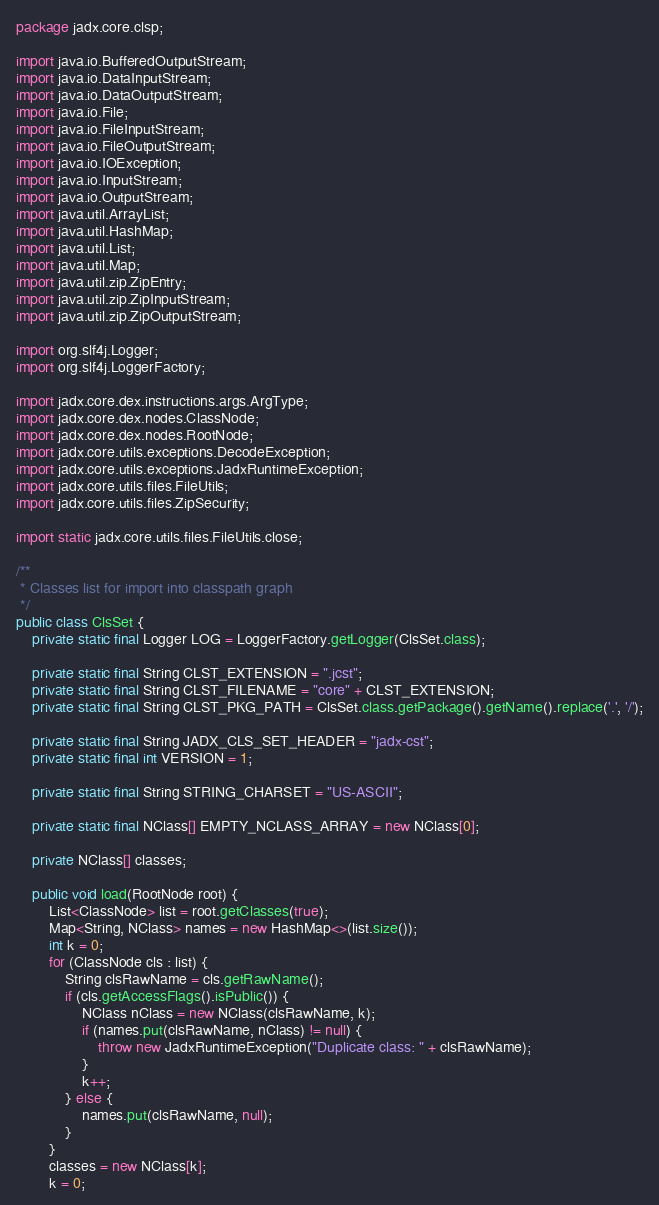<code> <loc_0><loc_0><loc_500><loc_500><_Java_>package jadx.core.clsp;

import java.io.BufferedOutputStream;
import java.io.DataInputStream;
import java.io.DataOutputStream;
import java.io.File;
import java.io.FileInputStream;
import java.io.FileOutputStream;
import java.io.IOException;
import java.io.InputStream;
import java.io.OutputStream;
import java.util.ArrayList;
import java.util.HashMap;
import java.util.List;
import java.util.Map;
import java.util.zip.ZipEntry;
import java.util.zip.ZipInputStream;
import java.util.zip.ZipOutputStream;

import org.slf4j.Logger;
import org.slf4j.LoggerFactory;

import jadx.core.dex.instructions.args.ArgType;
import jadx.core.dex.nodes.ClassNode;
import jadx.core.dex.nodes.RootNode;
import jadx.core.utils.exceptions.DecodeException;
import jadx.core.utils.exceptions.JadxRuntimeException;
import jadx.core.utils.files.FileUtils;
import jadx.core.utils.files.ZipSecurity;

import static jadx.core.utils.files.FileUtils.close;

/**
 * Classes list for import into classpath graph
 */
public class ClsSet {
	private static final Logger LOG = LoggerFactory.getLogger(ClsSet.class);

	private static final String CLST_EXTENSION = ".jcst";
	private static final String CLST_FILENAME = "core" + CLST_EXTENSION;
	private static final String CLST_PKG_PATH = ClsSet.class.getPackage().getName().replace('.', '/');

	private static final String JADX_CLS_SET_HEADER = "jadx-cst";
	private static final int VERSION = 1;

	private static final String STRING_CHARSET = "US-ASCII";

	private static final NClass[] EMPTY_NCLASS_ARRAY = new NClass[0];

	private NClass[] classes;

	public void load(RootNode root) {
		List<ClassNode> list = root.getClasses(true);
		Map<String, NClass> names = new HashMap<>(list.size());
		int k = 0;
		for (ClassNode cls : list) {
			String clsRawName = cls.getRawName();
			if (cls.getAccessFlags().isPublic()) {
				NClass nClass = new NClass(clsRawName, k);
				if (names.put(clsRawName, nClass) != null) {
					throw new JadxRuntimeException("Duplicate class: " + clsRawName);
				}
				k++;
			} else {
				names.put(clsRawName, null);
			}
		}
		classes = new NClass[k];
		k = 0;</code> 